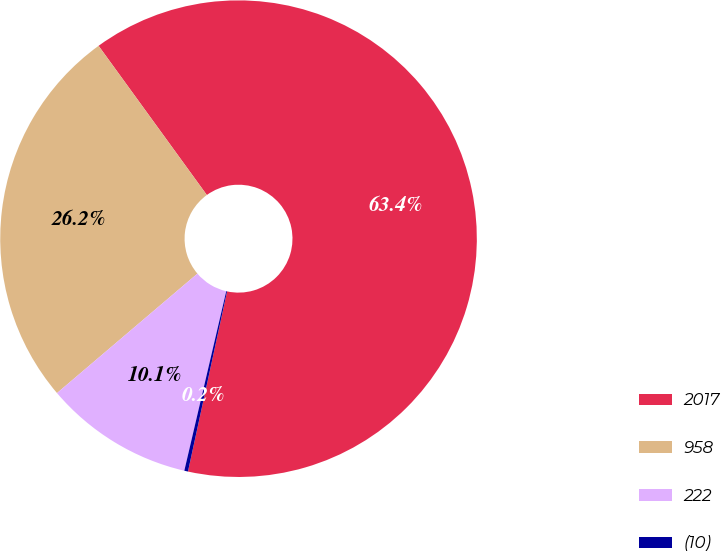Convert chart. <chart><loc_0><loc_0><loc_500><loc_500><pie_chart><fcel>2017<fcel>958<fcel>222<fcel>(10)<nl><fcel>63.4%<fcel>26.23%<fcel>10.13%<fcel>0.25%<nl></chart> 